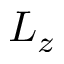<formula> <loc_0><loc_0><loc_500><loc_500>L _ { z }</formula> 